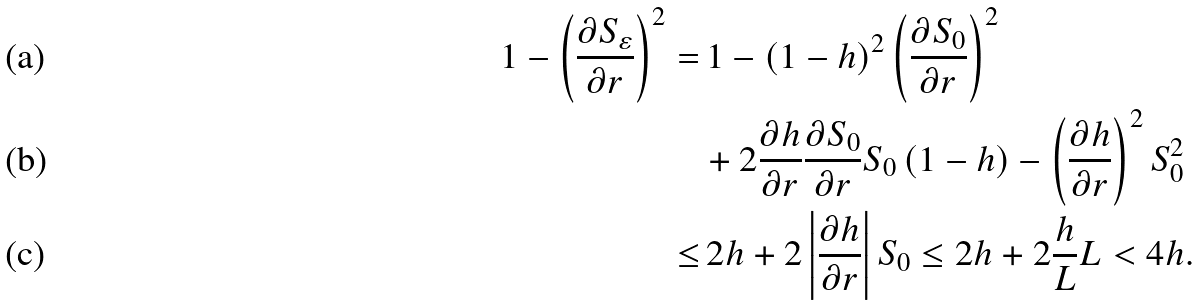Convert formula to latex. <formula><loc_0><loc_0><loc_500><loc_500>1 - \left ( \frac { \partial S _ { \varepsilon } } { \partial r } \right ) ^ { 2 } = & \, 1 - \left ( 1 - h \right ) ^ { 2 } \left ( \frac { \partial S _ { 0 } } { \partial r } \right ) ^ { 2 } \\ & + 2 \frac { \partial h } { \partial r } \frac { \partial S _ { 0 } } { \partial r } S _ { 0 } \left ( 1 - h \right ) - \left ( \frac { \partial h } { \partial r } \right ) ^ { 2 } S _ { 0 } ^ { 2 } \\ \leq & \, 2 h + 2 \left | \frac { \partial h } { \partial r } \right | S _ { 0 } \leq 2 h + 2 \frac { h } { L } L < 4 h .</formula> 